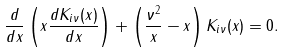<formula> <loc_0><loc_0><loc_500><loc_500>\frac { d } { d x } \left ( x \frac { d K _ { i \nu } ( x ) } { d x } \right ) + \left ( \frac { \nu ^ { 2 } } { x } - x \right ) K _ { i \nu } ( x ) = 0 .</formula> 